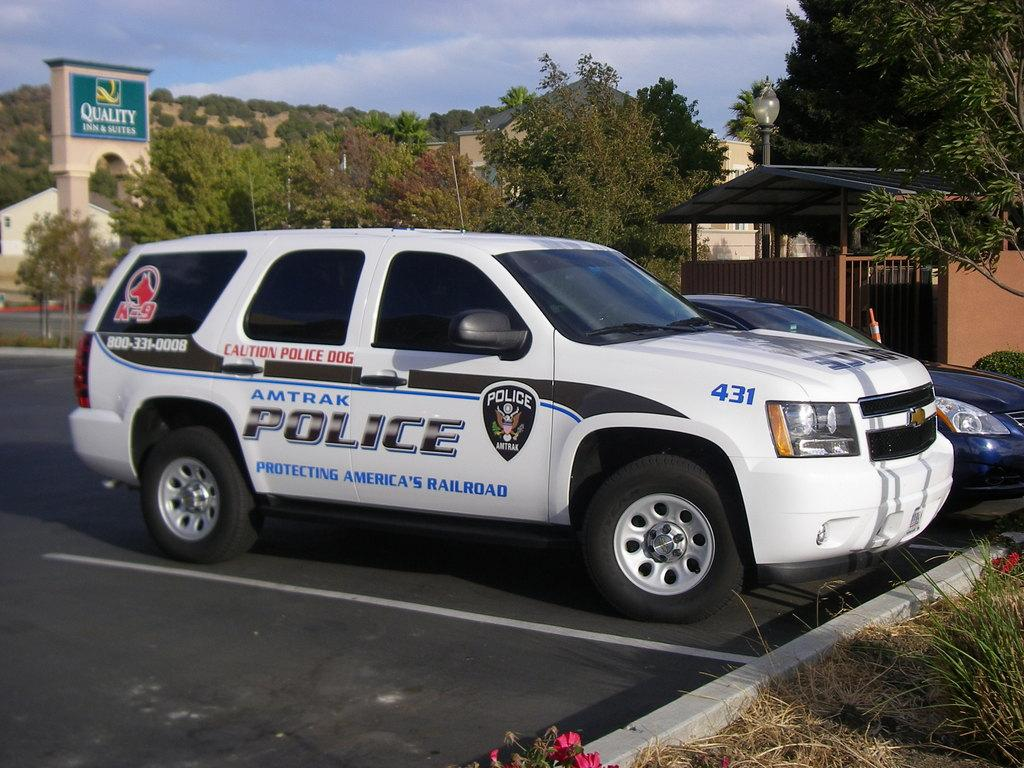What is the main subject in the foreground of the image? There is a police car in the foreground of the image. What can be seen in the middle of the image? There are trees and an arch in the middle of the image. What is visible at the top of the image? The sky is visible at the top of the image. Can you tell me how many goldfish are swimming in the arch in the image? There are no goldfish present in the image; the arch is a structure and not a body of water. 